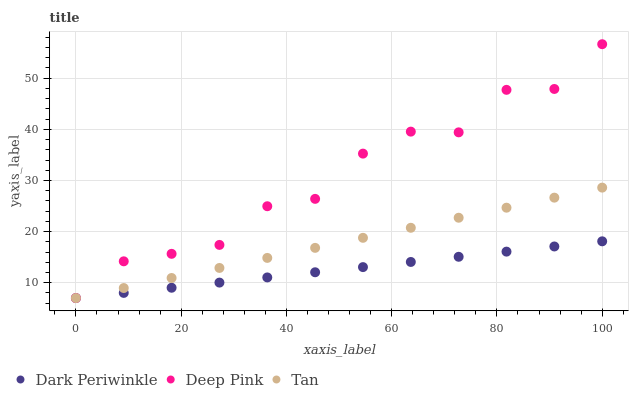Does Dark Periwinkle have the minimum area under the curve?
Answer yes or no. Yes. Does Deep Pink have the maximum area under the curve?
Answer yes or no. Yes. Does Deep Pink have the minimum area under the curve?
Answer yes or no. No. Does Dark Periwinkle have the maximum area under the curve?
Answer yes or no. No. Is Dark Periwinkle the smoothest?
Answer yes or no. Yes. Is Deep Pink the roughest?
Answer yes or no. Yes. Is Deep Pink the smoothest?
Answer yes or no. No. Is Dark Periwinkle the roughest?
Answer yes or no. No. Does Tan have the lowest value?
Answer yes or no. Yes. Does Deep Pink have the highest value?
Answer yes or no. Yes. Does Dark Periwinkle have the highest value?
Answer yes or no. No. Does Tan intersect Deep Pink?
Answer yes or no. Yes. Is Tan less than Deep Pink?
Answer yes or no. No. Is Tan greater than Deep Pink?
Answer yes or no. No. 